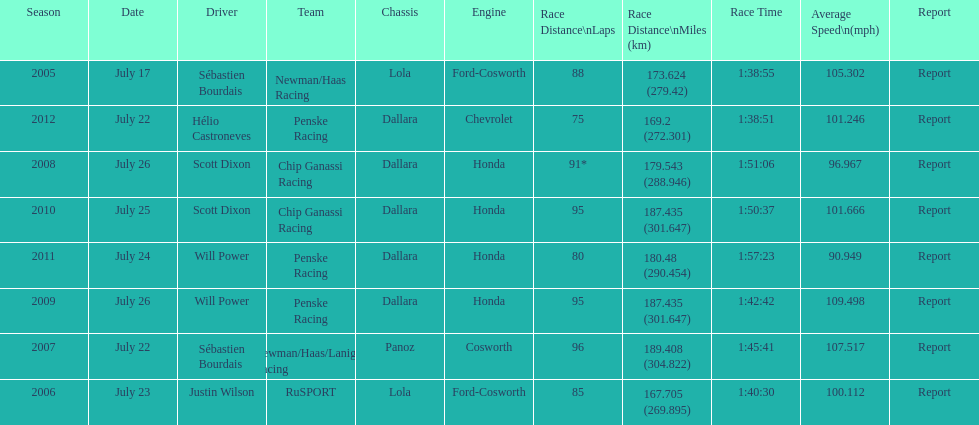Which team won the champ car world series the year before rusport? Newman/Haas Racing. 